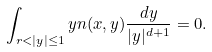Convert formula to latex. <formula><loc_0><loc_0><loc_500><loc_500>\int _ { r < | y | \leq 1 } y n ( x , y ) \frac { d y } { | y | ^ { d + 1 } } = 0 .</formula> 